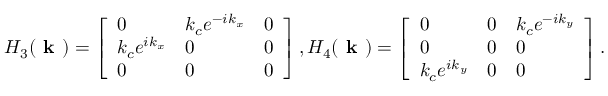<formula> <loc_0><loc_0><loc_500><loc_500>H _ { 3 } ( k ) = \left [ \begin{array} { l l l } { 0 } & { k _ { c } e ^ { - i k _ { x } } } & { 0 } \\ { k _ { c } e ^ { i k _ { x } } } & { 0 } & { 0 } \\ { 0 } & { 0 } & { 0 } \end{array} \right ] , H _ { 4 } ( k ) = \left [ \begin{array} { l l l } { 0 } & { 0 } & { k _ { c } e ^ { - i k _ { y } } } \\ { 0 } & { 0 } & { 0 } \\ { k _ { c } e ^ { i k _ { y } } } & { 0 } & { 0 } \end{array} \right ] .</formula> 